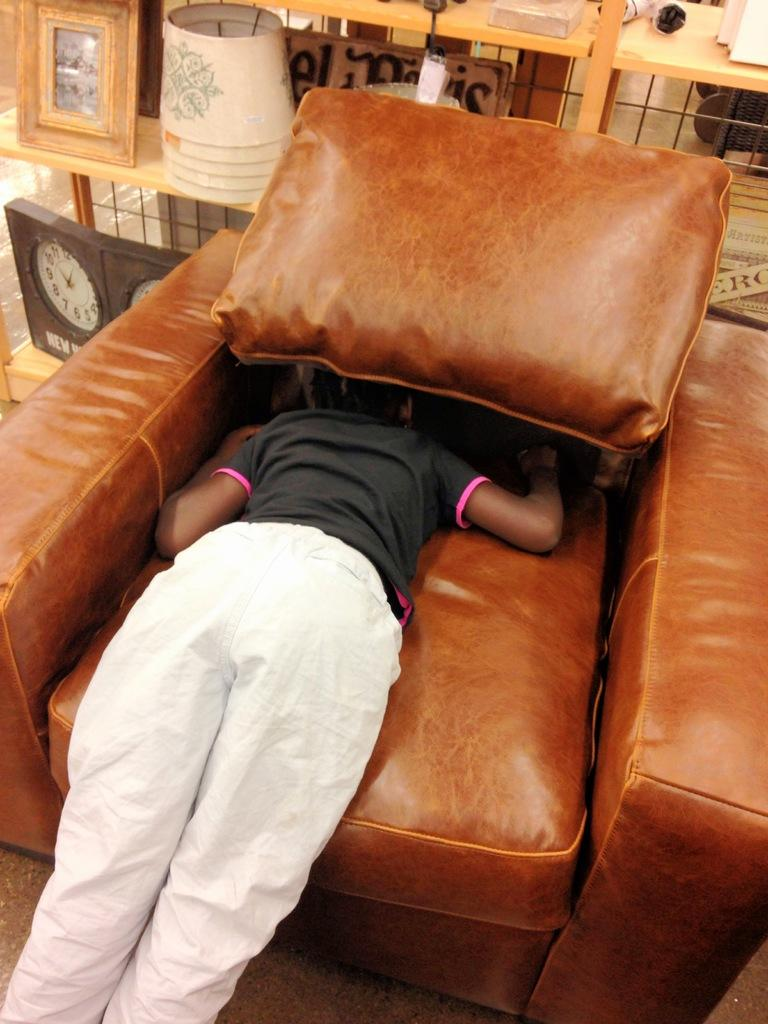What is the person in the image doing? The person is laying on the couch. What can be seen in the background of the image? There is a clock, a wooden board, and a railing in the background. What type of lock is visible on the railing in the image? There is no lock visible on the railing in the image. 